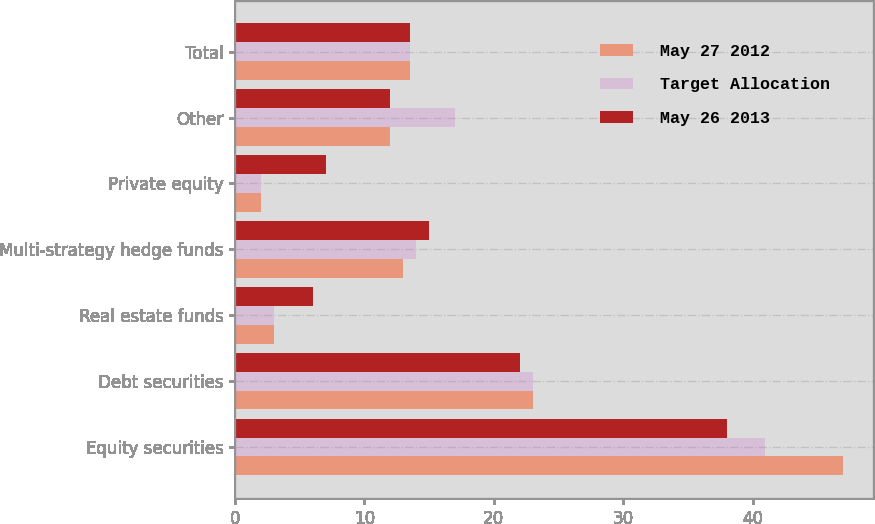Convert chart to OTSL. <chart><loc_0><loc_0><loc_500><loc_500><stacked_bar_chart><ecel><fcel>Equity securities<fcel>Debt securities<fcel>Real estate funds<fcel>Multi-strategy hedge funds<fcel>Private equity<fcel>Other<fcel>Total<nl><fcel>May 27 2012<fcel>47<fcel>23<fcel>3<fcel>13<fcel>2<fcel>12<fcel>13.5<nl><fcel>Target Allocation<fcel>41<fcel>23<fcel>3<fcel>14<fcel>2<fcel>17<fcel>13.5<nl><fcel>May 26 2013<fcel>38<fcel>22<fcel>6<fcel>15<fcel>7<fcel>12<fcel>13.5<nl></chart> 